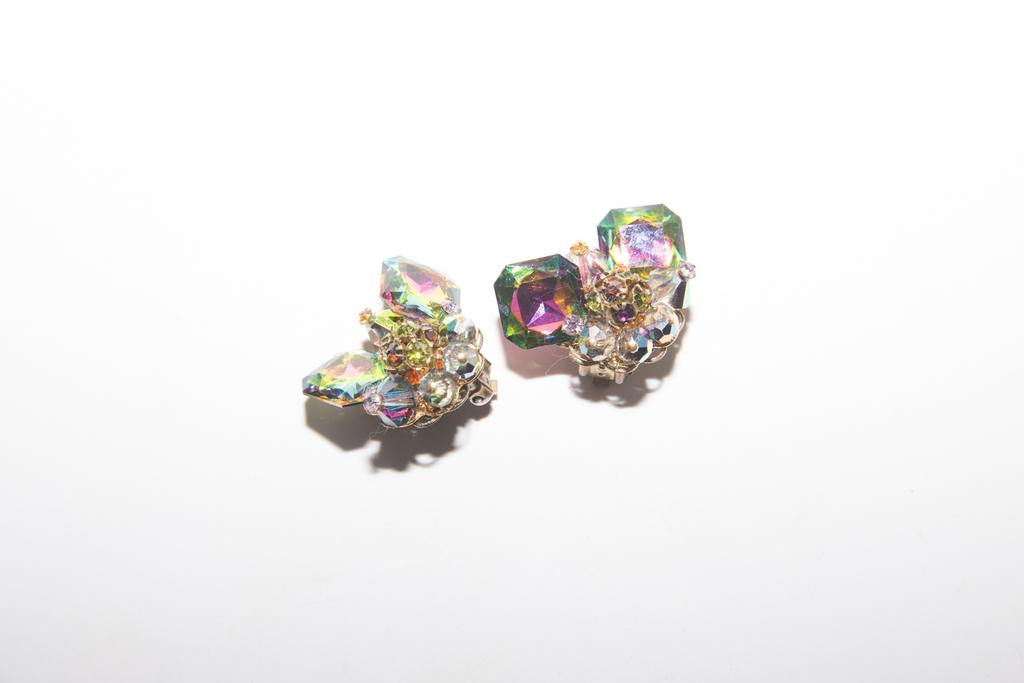How many jewelry items are visible in the image? There are two jewelry items in the image. What is the color of the surface on which the jewelry items are placed? The jewelry items are on a white surface. How many eggs are visible in the image? There are no eggs visible in the image; it features two jewelry items on a white surface. Who is the creator of the jewelry items in the image? The creator of the jewelry items is not mentioned or visible in the image. 